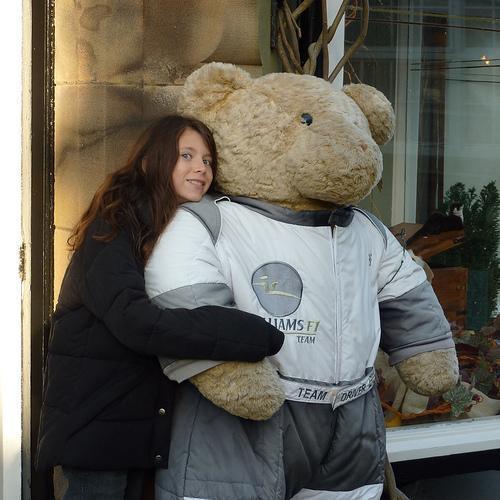How many people in the photo?
Give a very brief answer. 1. 